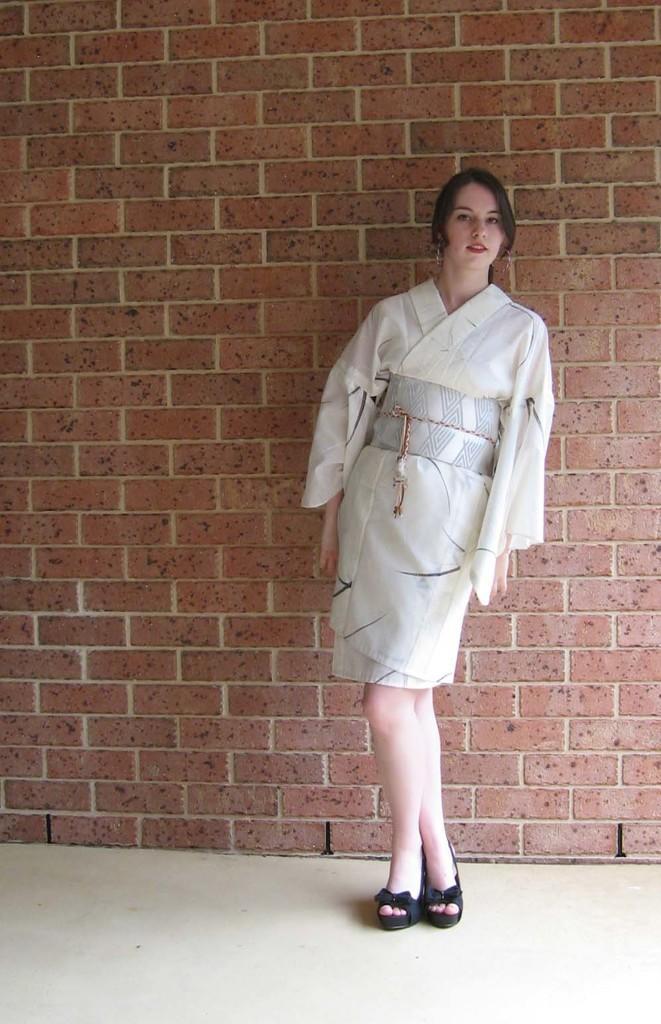Could you give a brief overview of what you see in this image? In this picture there is a girl who is standing on the right side of the image and there is a wall in the background area of the image. 